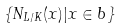<formula> <loc_0><loc_0><loc_500><loc_500>\{ N _ { L / K } ( x ) | x \in b \}</formula> 